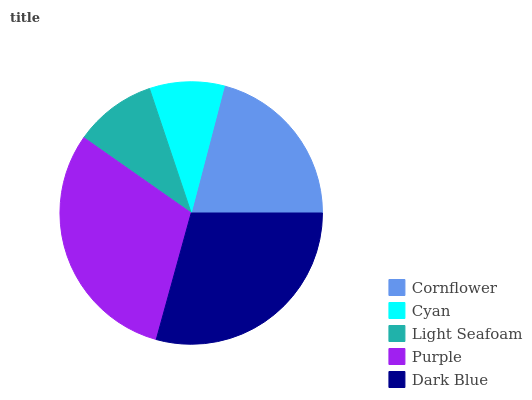Is Cyan the minimum?
Answer yes or no. Yes. Is Purple the maximum?
Answer yes or no. Yes. Is Light Seafoam the minimum?
Answer yes or no. No. Is Light Seafoam the maximum?
Answer yes or no. No. Is Light Seafoam greater than Cyan?
Answer yes or no. Yes. Is Cyan less than Light Seafoam?
Answer yes or no. Yes. Is Cyan greater than Light Seafoam?
Answer yes or no. No. Is Light Seafoam less than Cyan?
Answer yes or no. No. Is Cornflower the high median?
Answer yes or no. Yes. Is Cornflower the low median?
Answer yes or no. Yes. Is Cyan the high median?
Answer yes or no. No. Is Light Seafoam the low median?
Answer yes or no. No. 